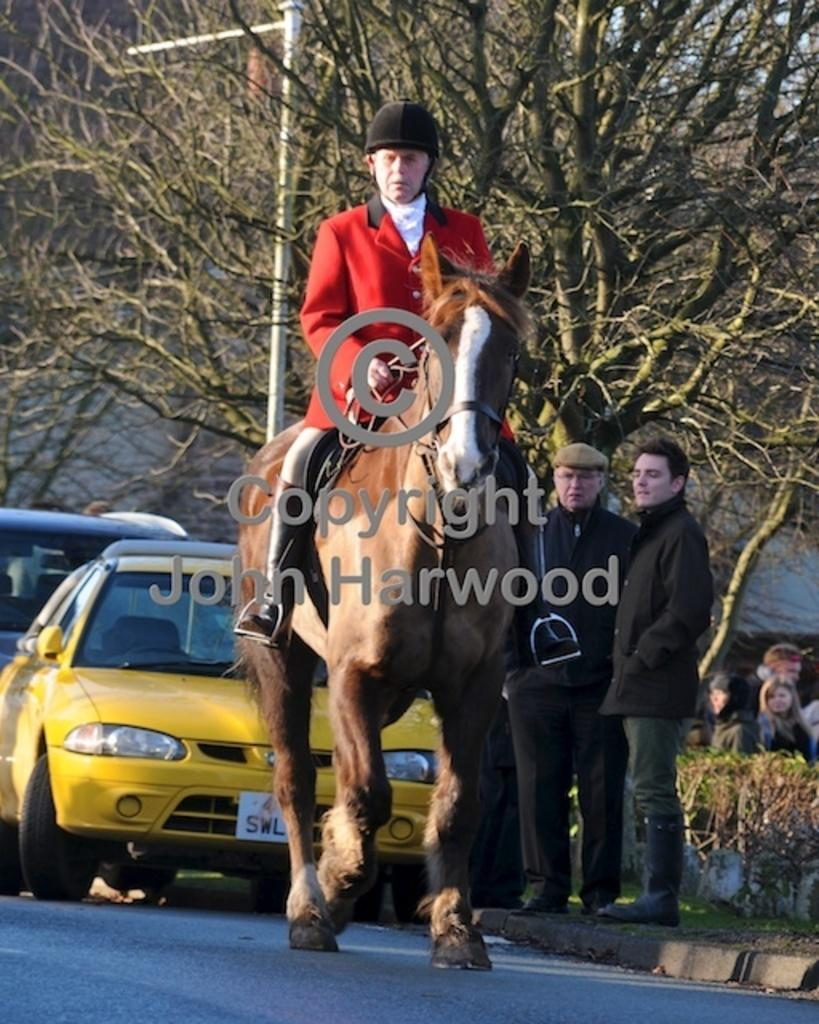What is the man in the image doing? The man in the image is riding a horse. Where is the man riding the horse located? The man is on a road. Are there any other people present in the image? Yes, there are other men standing behind the man on the horse. What other mode of transportation can be seen in the image? There is a car visible in the image. What type of division is being performed by the boys in the image? There are no boys present in the image, and therefore no division is being performed. What type of yam is being prepared by the men in the image? There is no yam present in the image, and no food preparation is depicted. 